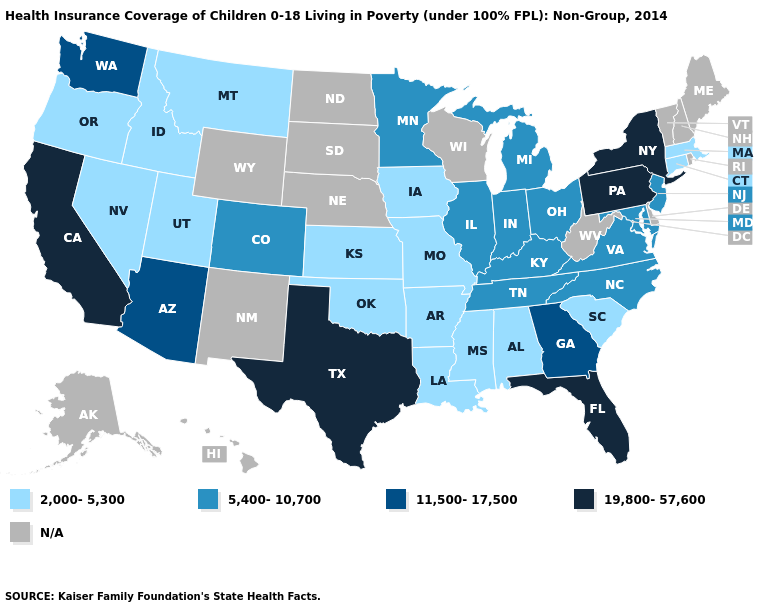What is the value of Oklahoma?
Answer briefly. 2,000-5,300. Is the legend a continuous bar?
Concise answer only. No. What is the value of Indiana?
Keep it brief. 5,400-10,700. Among the states that border Delaware , which have the lowest value?
Write a very short answer. Maryland, New Jersey. Name the states that have a value in the range 2,000-5,300?
Concise answer only. Alabama, Arkansas, Connecticut, Idaho, Iowa, Kansas, Louisiana, Massachusetts, Mississippi, Missouri, Montana, Nevada, Oklahoma, Oregon, South Carolina, Utah. What is the highest value in the Northeast ?
Give a very brief answer. 19,800-57,600. Does Louisiana have the highest value in the USA?
Give a very brief answer. No. Name the states that have a value in the range 5,400-10,700?
Concise answer only. Colorado, Illinois, Indiana, Kentucky, Maryland, Michigan, Minnesota, New Jersey, North Carolina, Ohio, Tennessee, Virginia. Name the states that have a value in the range 2,000-5,300?
Short answer required. Alabama, Arkansas, Connecticut, Idaho, Iowa, Kansas, Louisiana, Massachusetts, Mississippi, Missouri, Montana, Nevada, Oklahoma, Oregon, South Carolina, Utah. Which states have the lowest value in the West?
Answer briefly. Idaho, Montana, Nevada, Oregon, Utah. How many symbols are there in the legend?
Be succinct. 5. Is the legend a continuous bar?
Give a very brief answer. No. Name the states that have a value in the range 11,500-17,500?
Quick response, please. Arizona, Georgia, Washington. Among the states that border Illinois , which have the lowest value?
Keep it brief. Iowa, Missouri. What is the value of North Dakota?
Answer briefly. N/A. 